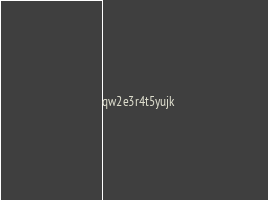<code> <loc_0><loc_0><loc_500><loc_500><_C#_>qw2e3r4t5yujk</code> 